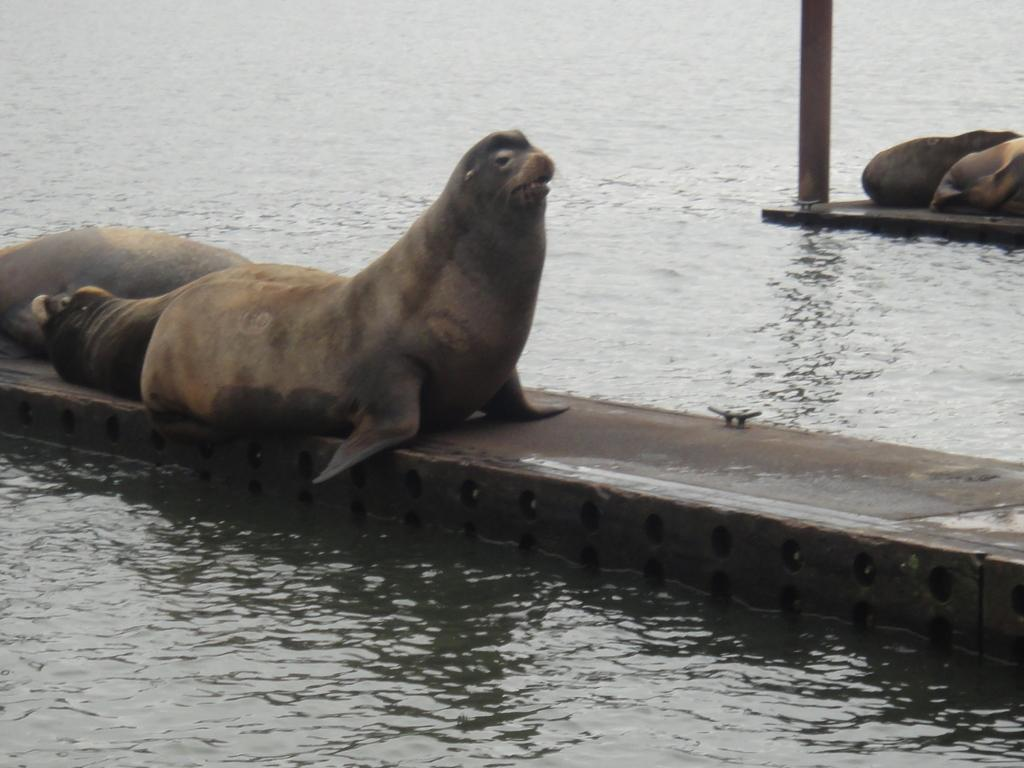How many seals can be seen in the image? There are four seals in the image. Where are the seals located? The seals are on a fence in the image. What other object is present in the image? There is a pole in the image. What can be inferred about the environment in the image? The presence of water suggests that the image may have been taken in the ocean. What type of star can be seen in the image? There is no star visible in the image; it features seals on a fence, a pole, and water. How many bananas are being held by the seals in the image? There are no bananas present in the image. 